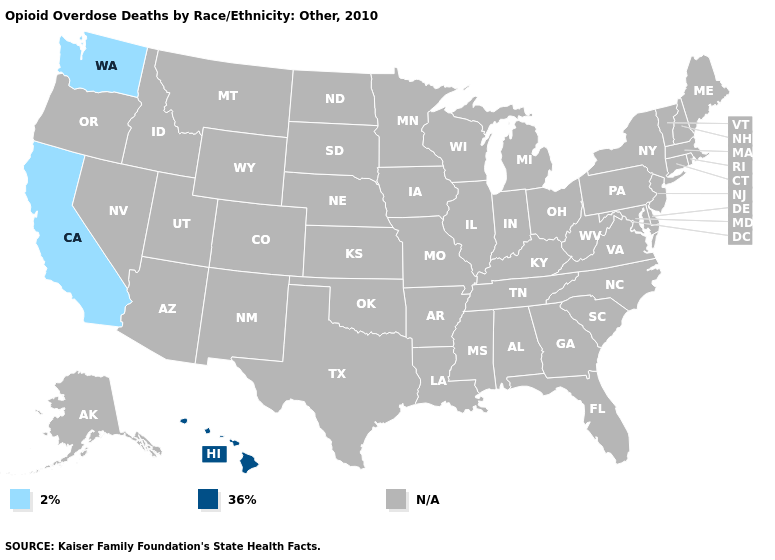What is the value of New Hampshire?
Keep it brief. N/A. Name the states that have a value in the range 2%?
Quick response, please. California, Washington. Name the states that have a value in the range 36%?
Answer briefly. Hawaii. What is the value of South Dakota?
Concise answer only. N/A. Name the states that have a value in the range 2%?
Be succinct. California, Washington. What is the highest value in the USA?
Answer briefly. 36%. Is the legend a continuous bar?
Concise answer only. No. Does Washington have the lowest value in the USA?
Write a very short answer. Yes. Name the states that have a value in the range 2%?
Give a very brief answer. California, Washington. Does Hawaii have the lowest value in the West?
Keep it brief. No. 